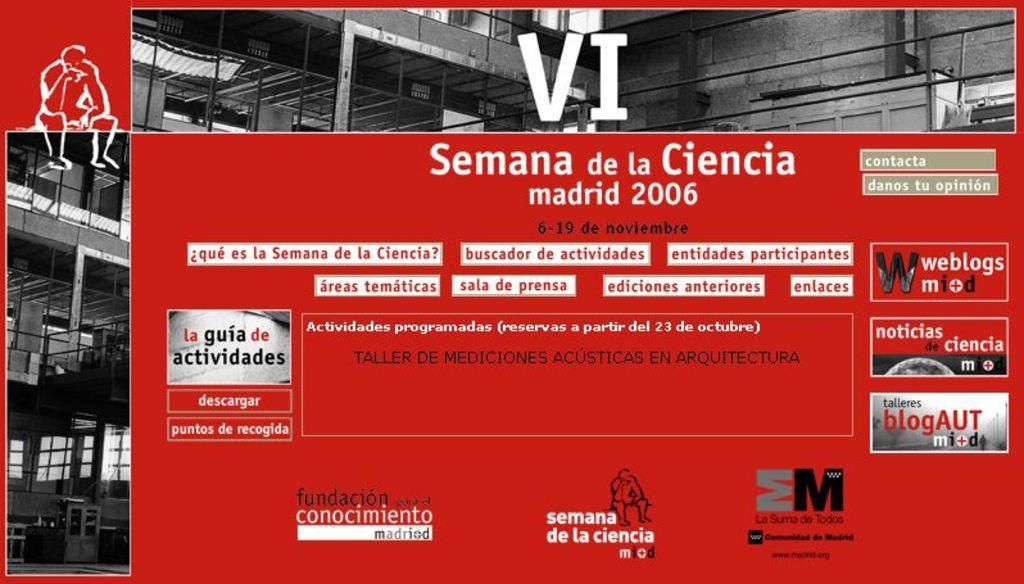What year is on this sign?
Give a very brief answer. 2006. What is the day and month written in black?
Your answer should be very brief. 6-19 de noviembre. 